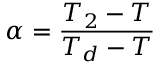Convert formula to latex. <formula><loc_0><loc_0><loc_500><loc_500>\alpha = { \frac { T _ { 2 } - T } { T _ { d } - T } }</formula> 